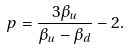<formula> <loc_0><loc_0><loc_500><loc_500>p = \frac { 3 \beta _ { u } } { \beta _ { u } - \beta _ { d } } - 2 .</formula> 